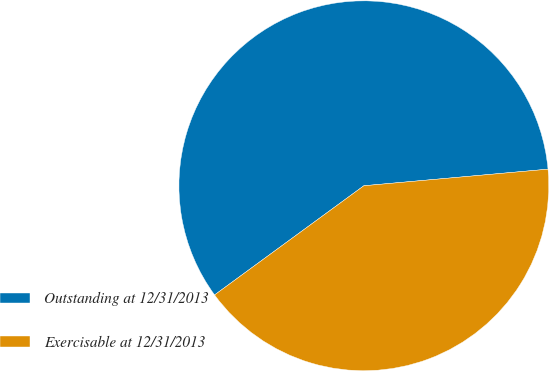Convert chart. <chart><loc_0><loc_0><loc_500><loc_500><pie_chart><fcel>Outstanding at 12/31/2013<fcel>Exercisable at 12/31/2013<nl><fcel>58.62%<fcel>41.38%<nl></chart> 